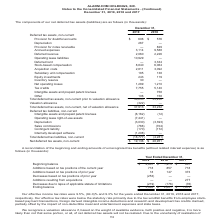Comparing values in Alarmcom Holdings's report, What was the effective income tax rate in 2019? According to the financial document, 9.5 (percentage). The relevant text states: "Our effective income tax rates were 9.5%, (84.0)% and 9.3% for the years ended December 31, 2019, 2018 and 2017, respectively. Our effectiv..." Also, What was the beginning balance in 2019? According to the financial document, 2,801 (in thousands). The relevant text states: "d December 31, 2019 2018 2017 Beginning balance $ 2,801 $ 1,973 $ 681 Additions based on tax positions of the current year 718 857 718 Additions based on t..." Also, Which years does the table provide information for the reconciliation of the beginning and ending amounts of unrecognized tax benefits? The document contains multiple relevant values: 2019, 2018, 2017. From the document: "Year Ended December 31, 2019 2018 2017 Beginning balance $ 2,801 $ 1,973 $ 681 Additions based on tax positions of the current year 718 85 Year Ended ..." Also, How many years did the beginning balance exceed $2,000 thousand? Based on the analysis, there are 1 instances. The counting process: 2019. Also, can you calculate: What was the change in the Additions based on tax positions of prior year between 2017 and 2018? Based on the calculation: 147-373, the result is -226 (in thousands). This is based on the information: "tions based on tax positions of prior year 18 147 373 Decreases based on tax positions of prior year (253) — — Additions resulting from acquisitions — — Additions based on tax positions of prior year ..." The key data points involved are: 147, 373. Also, can you calculate: What was the percentage change in the ending balance between 2018 and 2019? To answer this question, I need to perform calculations using the financial data. The calculation is: (3,065-2,801)/2,801, which equals 9.43 (percentage). This is based on the information: "of limitations (219) (176) (76) Ending balance $ 3,065 $ 2,801 $ 1,973 d December 31, 2019 2018 2017 Beginning balance $ 2,801 $ 1,973 $ 681 Additions based on tax positions of the current year 718 85..." The key data points involved are: 2,801, 3,065. 